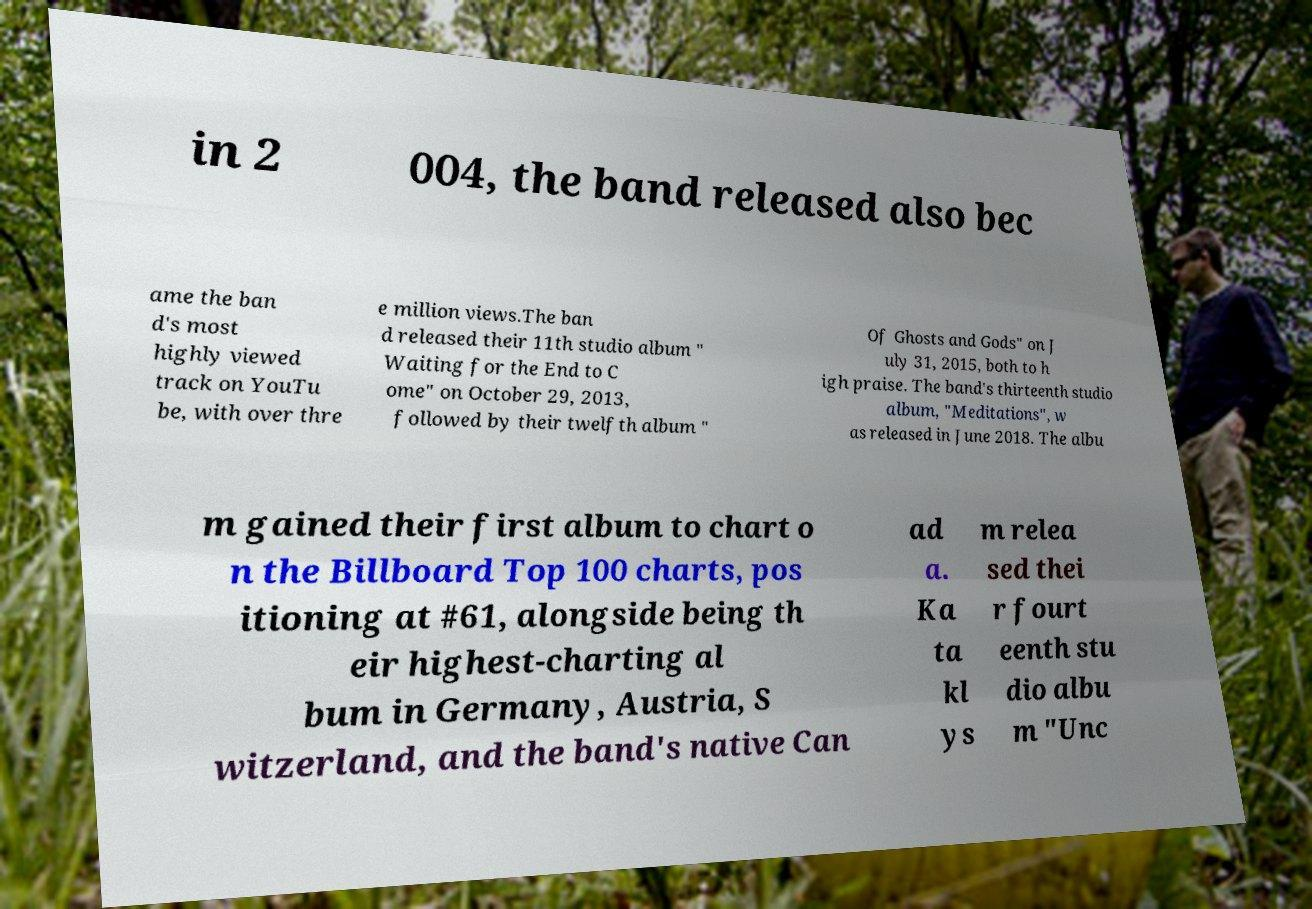Could you extract and type out the text from this image? in 2 004, the band released also bec ame the ban d's most highly viewed track on YouTu be, with over thre e million views.The ban d released their 11th studio album " Waiting for the End to C ome" on October 29, 2013, followed by their twelfth album " Of Ghosts and Gods" on J uly 31, 2015, both to h igh praise. The band's thirteenth studio album, "Meditations", w as released in June 2018. The albu m gained their first album to chart o n the Billboard Top 100 charts, pos itioning at #61, alongside being th eir highest-charting al bum in Germany, Austria, S witzerland, and the band's native Can ad a. Ka ta kl ys m relea sed thei r fourt eenth stu dio albu m "Unc 